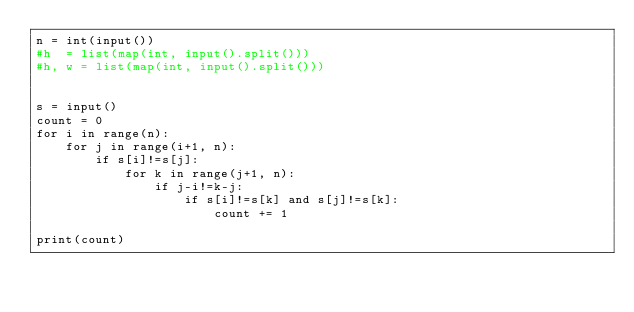Convert code to text. <code><loc_0><loc_0><loc_500><loc_500><_Python_>n = int(input())
#h  = list(map(int, input().split()))
#h, w = list(map(int, input().split()))


s = input()
count = 0
for i in range(n):
    for j in range(i+1, n):
        if s[i]!=s[j]:    
            for k in range(j+1, n):
                if j-i!=k-j:
                    if s[i]!=s[k] and s[j]!=s[k]:
                        count += 1

print(count)



</code> 